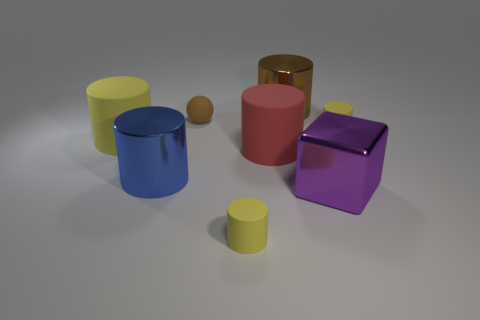Is the color of the metal block the same as the large rubber object that is to the left of the blue cylinder? No, the color of the metallic cube differs from that of the large rubber object near the blue cylinder; the cube exhibits a reflective purple shade while the rubber object has a matte red hue. 